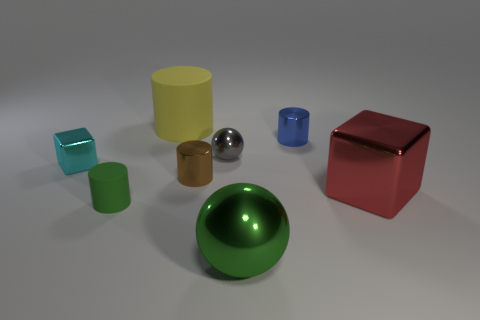Could you guess the setting or purpose of this arrangement? This arrangement could be part of a visual study or an artistic composition, aimed at showcasing the interaction of colors, light, and textures among simple geometric shapes. 